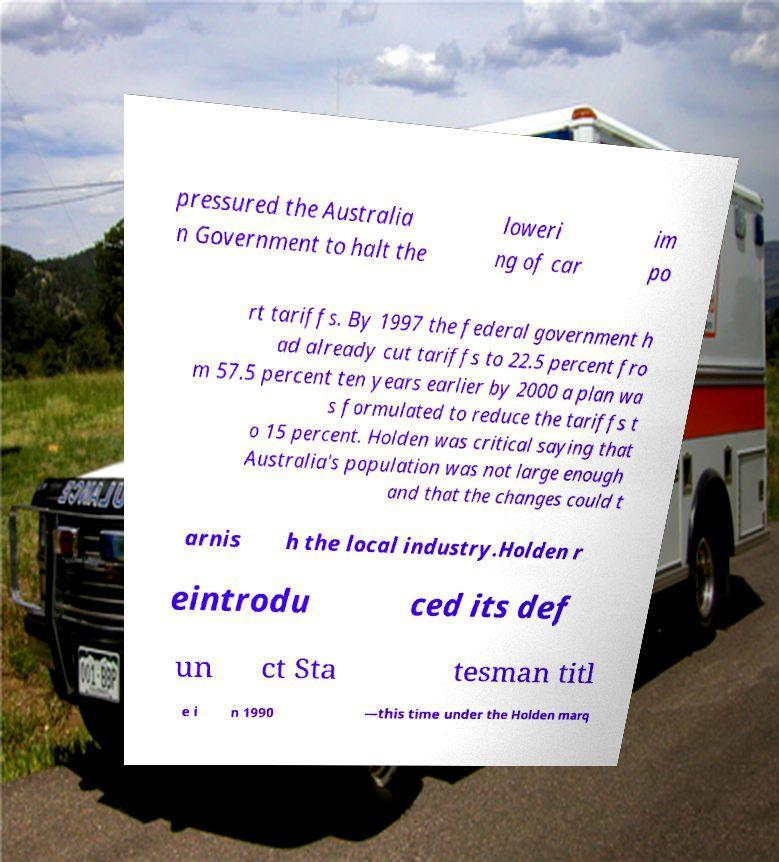Can you read and provide the text displayed in the image?This photo seems to have some interesting text. Can you extract and type it out for me? pressured the Australia n Government to halt the loweri ng of car im po rt tariffs. By 1997 the federal government h ad already cut tariffs to 22.5 percent fro m 57.5 percent ten years earlier by 2000 a plan wa s formulated to reduce the tariffs t o 15 percent. Holden was critical saying that Australia's population was not large enough and that the changes could t arnis h the local industry.Holden r eintrodu ced its def un ct Sta tesman titl e i n 1990 —this time under the Holden marq 